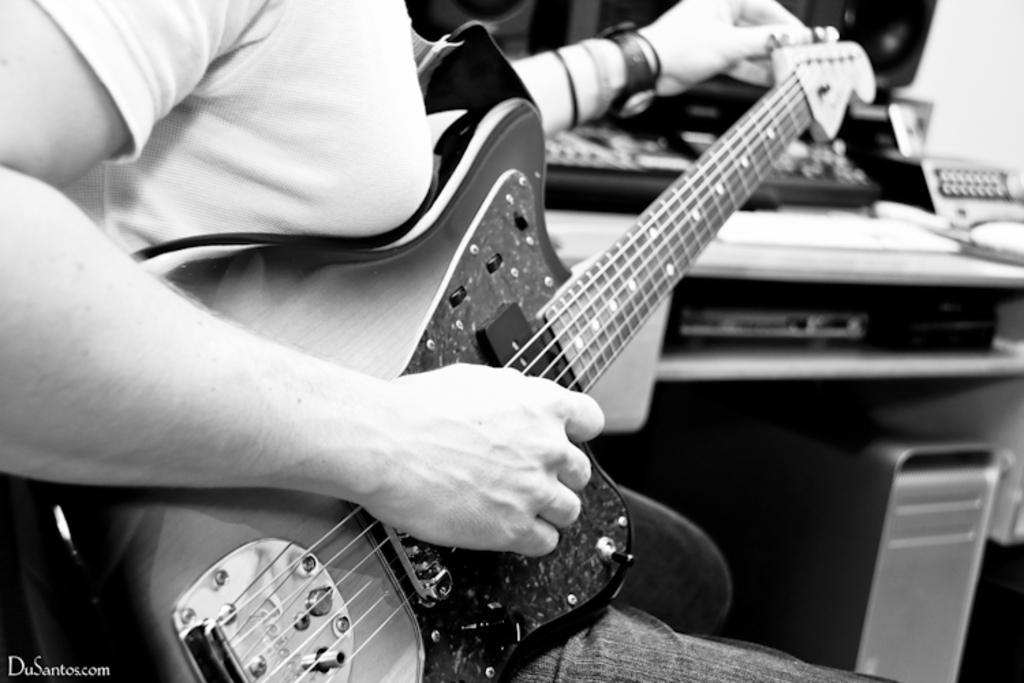Describe this image in one or two sentences. In this image I can a person holding guitar in hands. On the right side there is a table on which few objects are placed. 